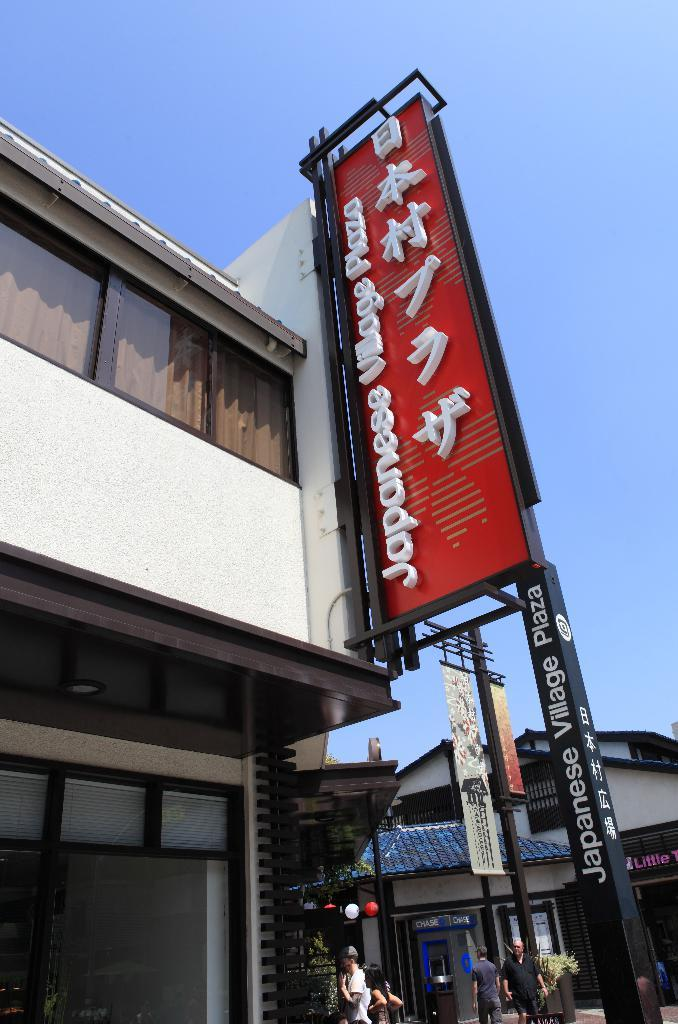What type of structures are present in the image? There are buildings in the image. What feature do the buildings have? The buildings have glass windows. What else can be seen in the image besides the buildings? There is an LED hoarding board pole and four persons at the bottom of the image. What is visible in the sky in the image? There are clouds in the sky. Can you tell me how many goats are grazing near the river in the image? There is no river or goats present in the image; it features buildings, an LED hoarding board pole, and four persons at the bottom. 